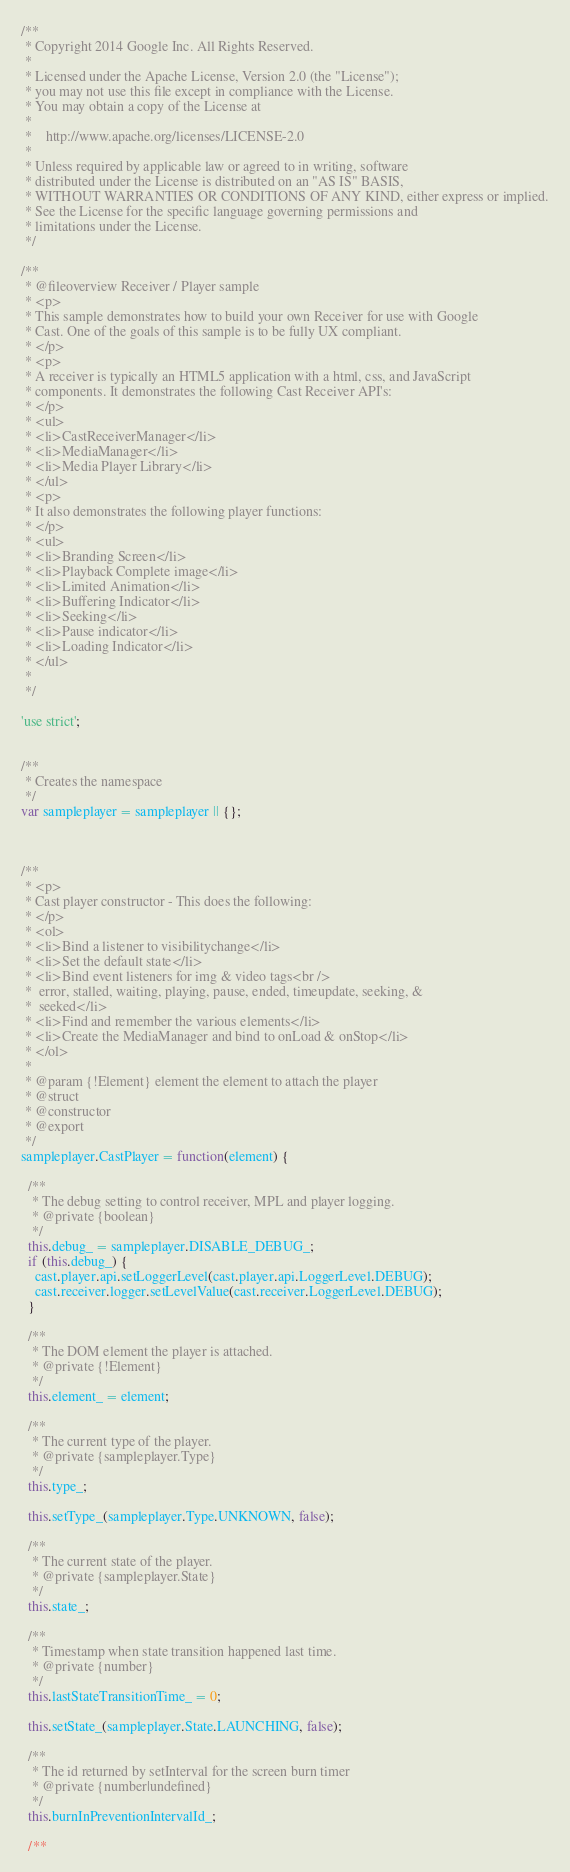<code> <loc_0><loc_0><loc_500><loc_500><_JavaScript_>/**
 * Copyright 2014 Google Inc. All Rights Reserved.
 *
 * Licensed under the Apache License, Version 2.0 (the "License");
 * you may not use this file except in compliance with the License.
 * You may obtain a copy of the License at
 *
 *    http://www.apache.org/licenses/LICENSE-2.0
 *
 * Unless required by applicable law or agreed to in writing, software
 * distributed under the License is distributed on an "AS IS" BASIS,
 * WITHOUT WARRANTIES OR CONDITIONS OF ANY KIND, either express or implied.
 * See the License for the specific language governing permissions and
 * limitations under the License.
 */

/**
 * @fileoverview Receiver / Player sample
 * <p>
 * This sample demonstrates how to build your own Receiver for use with Google
 * Cast. One of the goals of this sample is to be fully UX compliant.
 * </p>
 * <p>
 * A receiver is typically an HTML5 application with a html, css, and JavaScript
 * components. It demonstrates the following Cast Receiver API's:
 * </p>
 * <ul>
 * <li>CastReceiverManager</li>
 * <li>MediaManager</li>
 * <li>Media Player Library</li>
 * </ul>
 * <p>
 * It also demonstrates the following player functions:
 * </p>
 * <ul>
 * <li>Branding Screen</li>
 * <li>Playback Complete image</li>
 * <li>Limited Animation</li>
 * <li>Buffering Indicator</li>
 * <li>Seeking</li>
 * <li>Pause indicator</li>
 * <li>Loading Indicator</li>
 * </ul>
 *
 */

'use strict';


/**
 * Creates the namespace
 */
var sampleplayer = sampleplayer || {};



/**
 * <p>
 * Cast player constructor - This does the following:
 * </p>
 * <ol>
 * <li>Bind a listener to visibilitychange</li>
 * <li>Set the default state</li>
 * <li>Bind event listeners for img & video tags<br />
 *  error, stalled, waiting, playing, pause, ended, timeupdate, seeking, &
 *  seeked</li>
 * <li>Find and remember the various elements</li>
 * <li>Create the MediaManager and bind to onLoad & onStop</li>
 * </ol>
 *
 * @param {!Element} element the element to attach the player
 * @struct
 * @constructor
 * @export
 */
sampleplayer.CastPlayer = function(element) {

  /**
   * The debug setting to control receiver, MPL and player logging.
   * @private {boolean}
   */
  this.debug_ = sampleplayer.DISABLE_DEBUG_;
  if (this.debug_) {
    cast.player.api.setLoggerLevel(cast.player.api.LoggerLevel.DEBUG);
    cast.receiver.logger.setLevelValue(cast.receiver.LoggerLevel.DEBUG);
  }

  /**
   * The DOM element the player is attached.
   * @private {!Element}
   */
  this.element_ = element;

  /**
   * The current type of the player.
   * @private {sampleplayer.Type}
   */
  this.type_;

  this.setType_(sampleplayer.Type.UNKNOWN, false);

  /**
   * The current state of the player.
   * @private {sampleplayer.State}
   */
  this.state_;

  /**
   * Timestamp when state transition happened last time.
   * @private {number}
   */
  this.lastStateTransitionTime_ = 0;

  this.setState_(sampleplayer.State.LAUNCHING, false);

  /**
   * The id returned by setInterval for the screen burn timer
   * @private {number|undefined}
   */
  this.burnInPreventionIntervalId_;

  /**</code> 